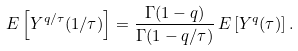Convert formula to latex. <formula><loc_0><loc_0><loc_500><loc_500>{ E } \left [ Y ^ { q / \tau } ( 1 / \tau ) \right ] = \frac { \Gamma ( 1 - q ) } { \Gamma ( 1 - q / \tau ) } \, { E } \left [ Y ^ { q } ( \tau ) \right ] .</formula> 